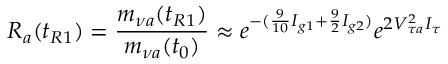<formula> <loc_0><loc_0><loc_500><loc_500>R _ { a } ( t _ { R 1 } ) = \frac { m _ { \nu a } ( t _ { R 1 } ) } { m _ { \nu a } ( t _ { 0 } ) } \approx e ^ { - ( \frac { 9 } { 1 0 } I _ { g 1 } + \frac { 9 } { 2 } I _ { g 2 } ) } e ^ { 2 V _ { \tau a } ^ { 2 } I _ { \tau } }</formula> 